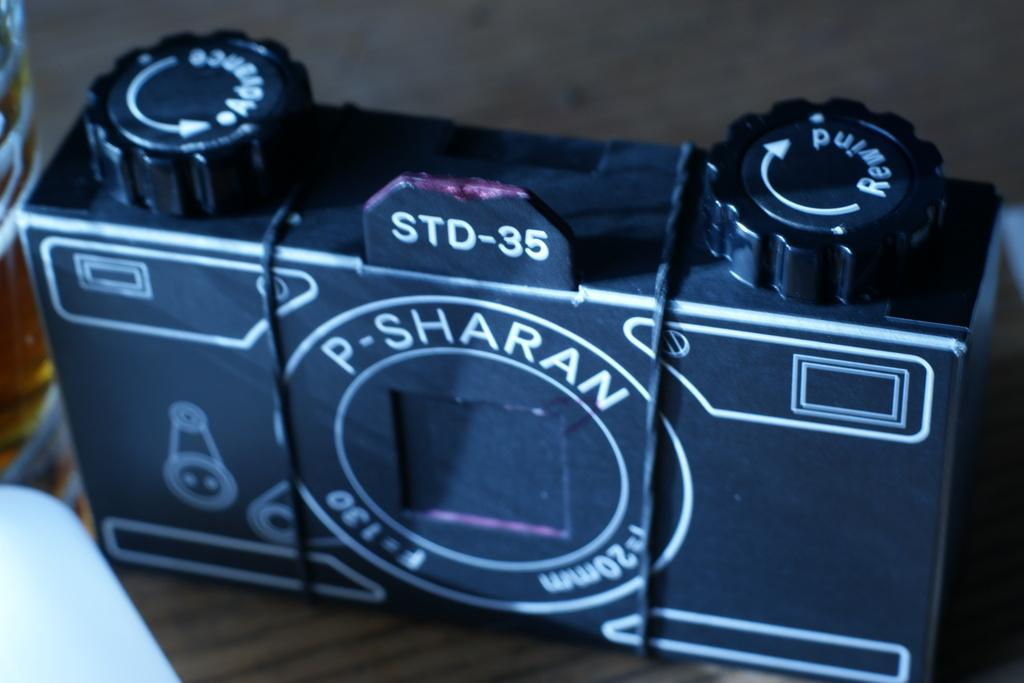Provide a one-sentence caption for the provided image. a camera that has the word sharan on it. 